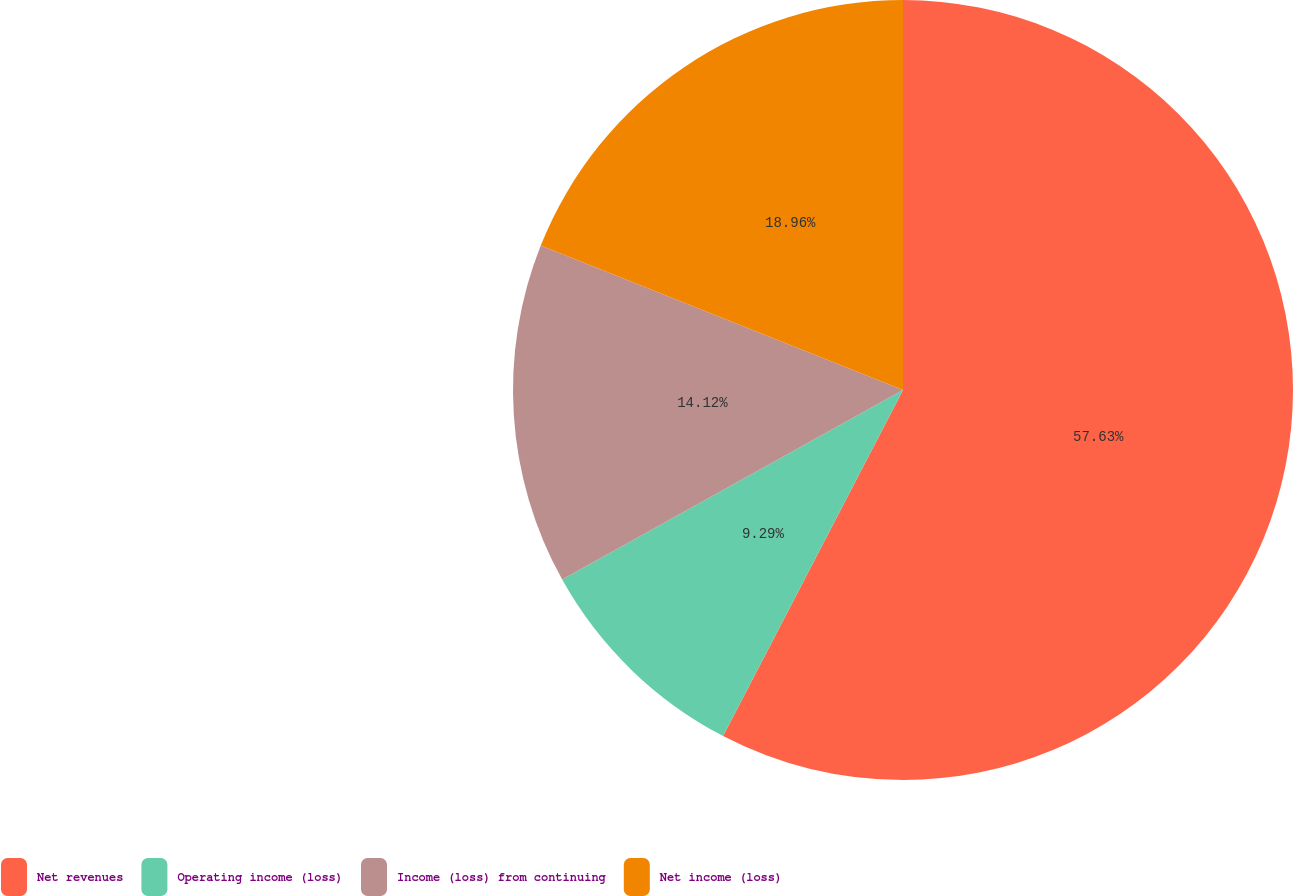<chart> <loc_0><loc_0><loc_500><loc_500><pie_chart><fcel>Net revenues<fcel>Operating income (loss)<fcel>Income (loss) from continuing<fcel>Net income (loss)<nl><fcel>57.63%<fcel>9.29%<fcel>14.12%<fcel>18.96%<nl></chart> 